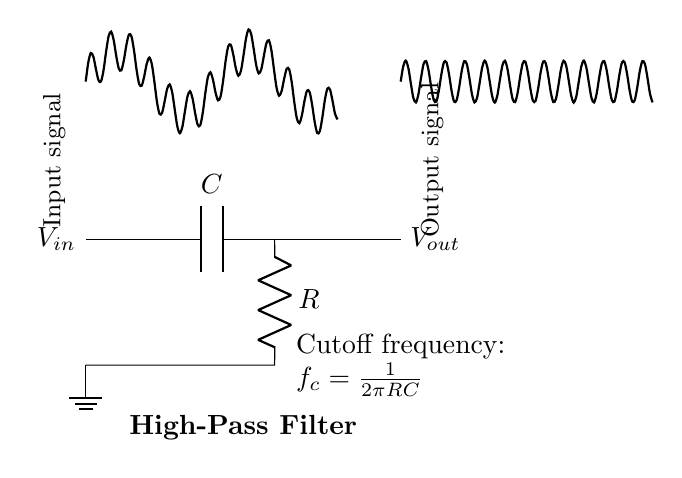What type of filter is represented in this circuit? The circuit is labeled as a High-Pass Filter, which indicates its function of allowing high-frequency signals to pass while attenuating lower-frequency signals.
Answer: High-Pass Filter What is the cutoff frequency formula in this circuit? The formula for cutoff frequency is provided in the diagram as f_c = 1/(2πRC), which is fundamental in determining the frequency at which the output starts to drop off.
Answer: f_c = 1/(2πRC) What components are present in this high-pass filter circuit? The circuit diagram clearly shows a capacitor and a resistor, indicating that these two components are essential for the operation of the high-pass filter.
Answer: Capacitor and Resistor How many input/output connections are shown in this diagram? There is one input connection labeled V_in and one output connection labeled V_out, totaling two connections in the circuit.
Answer: Two connections What is the effect of the capacitor on low-frequency signals in this circuit? The capacitor blocks low-frequency signals from passing through to the output, effectively isolating higher frequency components as per the design of a high-pass filter.
Answer: Blocks low-frequency signals What happens to high-frequency signals in this circuit? High-frequency signals pass through the capacitor and resistor combination unaffected, allowing them to appear at the output.
Answer: Passes unchanged At what point is the ground reference indicated in this circuit? The ground is marked directly below the resistor, establishing a common return path for current and serving as a reference point for the circuit.
Answer: Below the resistor 